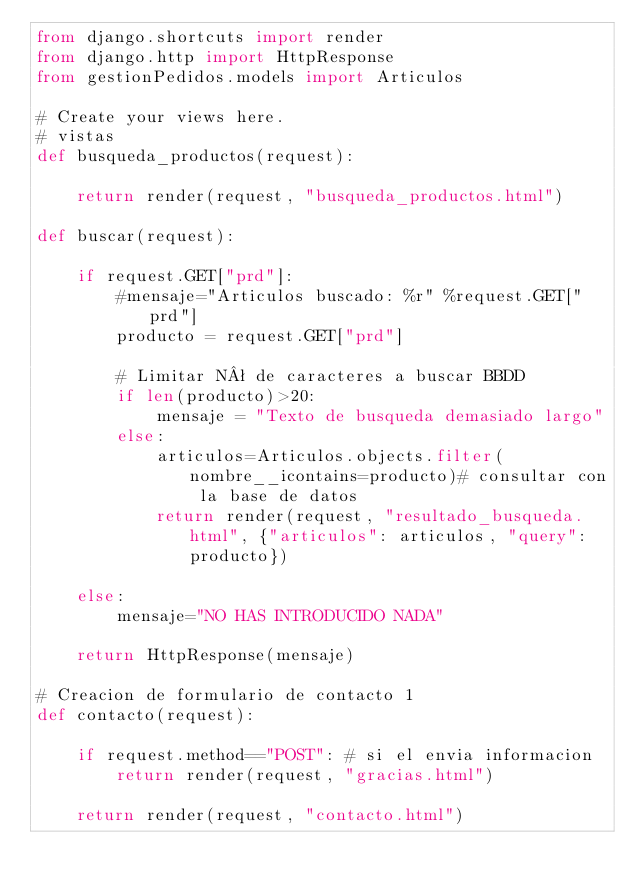<code> <loc_0><loc_0><loc_500><loc_500><_Python_>from django.shortcuts import render
from django.http import HttpResponse
from gestionPedidos.models import Articulos

# Create your views here.
# vistas
def busqueda_productos(request):

    return render(request, "busqueda_productos.html")

def buscar(request):

    if request.GET["prd"]:
        #mensaje="Articulos buscado: %r" %request.GET["prd"]
        producto = request.GET["prd"]

        # Limitar Nª de caracteres a buscar BBDD
        if len(producto)>20:
            mensaje = "Texto de busqueda demasiado largo"
        else:
            articulos=Articulos.objects.filter(nombre__icontains=producto)# consultar con la base de datos
            return render(request, "resultado_busqueda.html", {"articulos": articulos, "query":producto})
        
    else:
        mensaje="NO HAS INTRODUCIDO NADA"

    return HttpResponse(mensaje)

# Creacion de formulario de contacto 1
def contacto(request):

    if request.method=="POST": # si el envia informacion
        return render(request, "gracias.html")
        
    return render(request, "contacto.html")</code> 